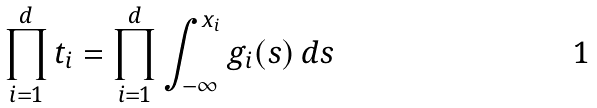Convert formula to latex. <formula><loc_0><loc_0><loc_500><loc_500>\prod _ { i = 1 } ^ { d } t _ { i } = \prod _ { i = 1 } ^ { d } \int _ { - \infty } ^ { x _ { i } } g _ { i } ( s ) \, d s</formula> 